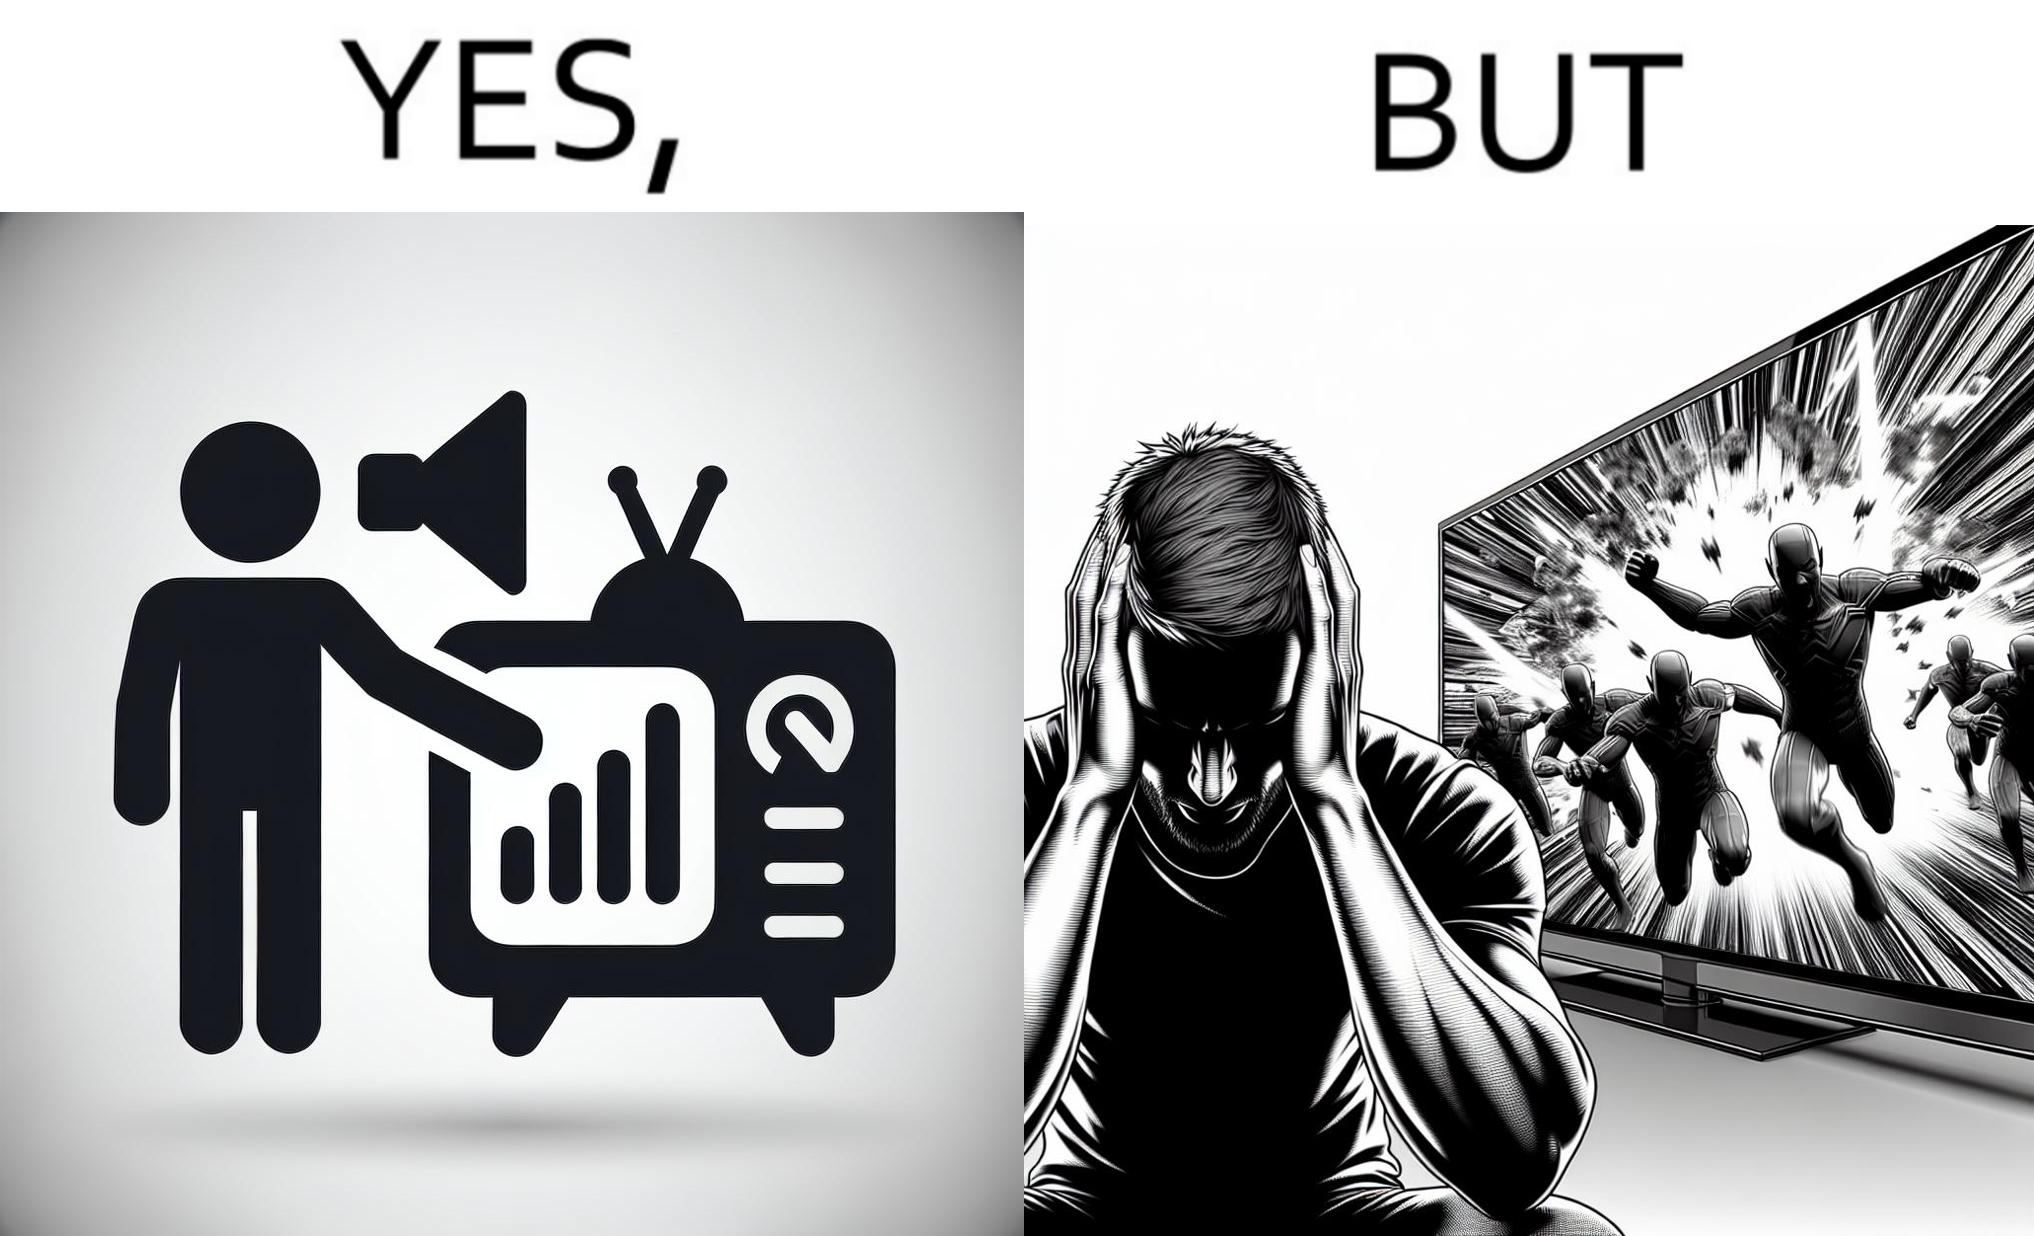What is shown in the left half versus the right half of this image? In the left part of the image: a person watching TV and increasing the volume of TV, maybe because he is not able to hear the dialogues properly In the right part of the image: a person covering his ears from the loud noise of TV, maybe because of the action scenes 